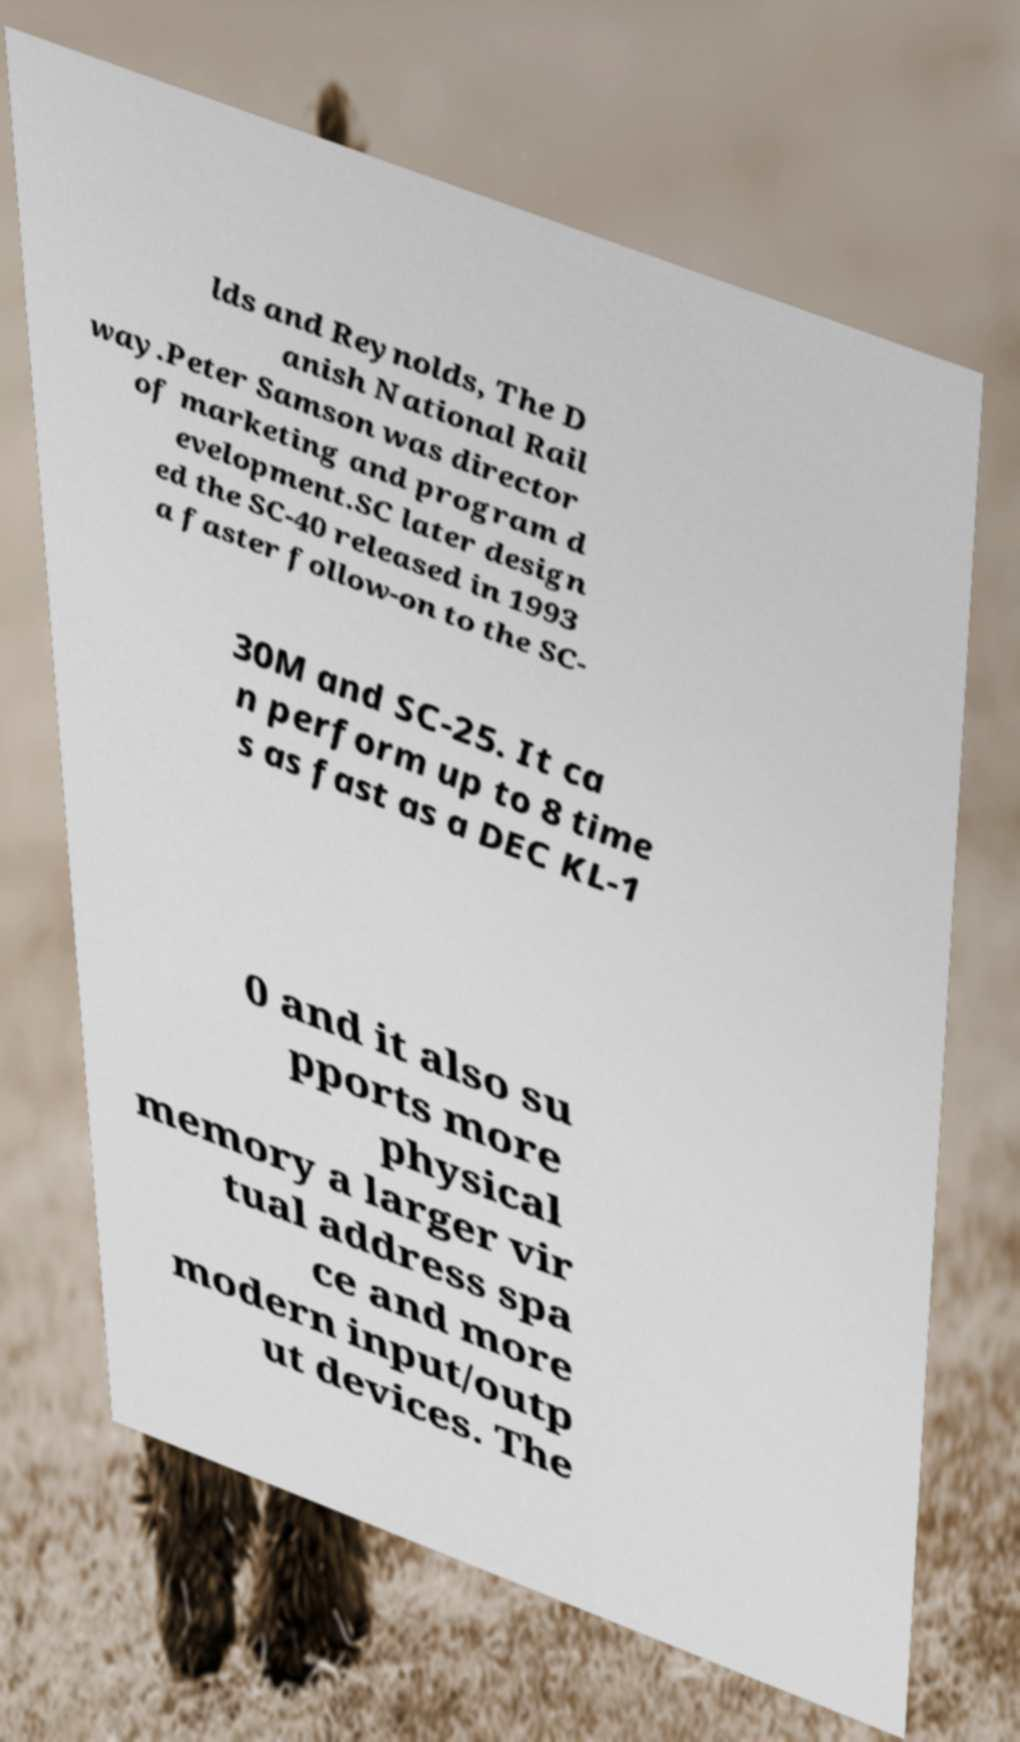Can you read and provide the text displayed in the image?This photo seems to have some interesting text. Can you extract and type it out for me? lds and Reynolds, The D anish National Rail way.Peter Samson was director of marketing and program d evelopment.SC later design ed the SC-40 released in 1993 a faster follow-on to the SC- 30M and SC-25. It ca n perform up to 8 time s as fast as a DEC KL-1 0 and it also su pports more physical memory a larger vir tual address spa ce and more modern input/outp ut devices. The 